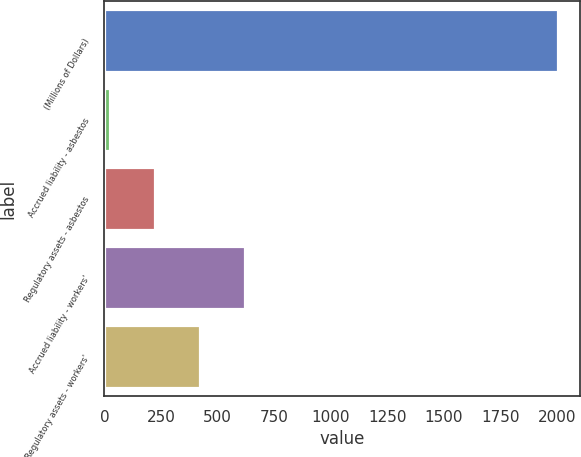Convert chart. <chart><loc_0><loc_0><loc_500><loc_500><bar_chart><fcel>(Millions of Dollars)<fcel>Accrued liability - asbestos<fcel>Regulatory assets - asbestos<fcel>Accrued liability - workers'<fcel>Regulatory assets - workers'<nl><fcel>2004<fcel>26<fcel>223.8<fcel>619.4<fcel>421.6<nl></chart> 